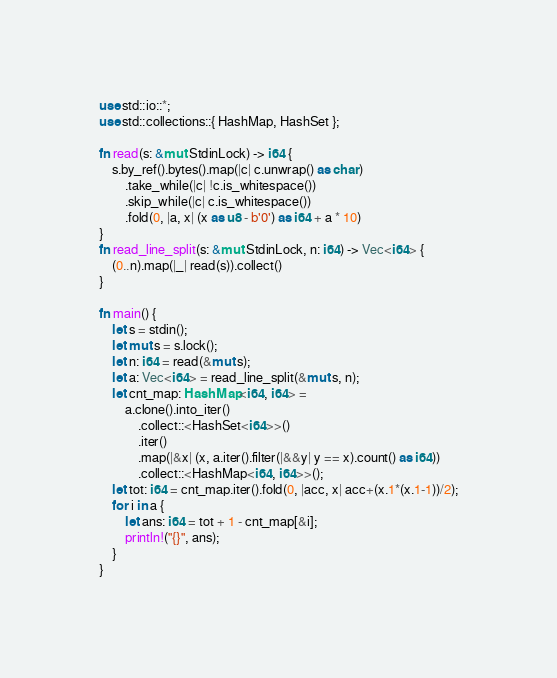Convert code to text. <code><loc_0><loc_0><loc_500><loc_500><_Rust_>use std::io::*;
use std::collections::{ HashMap, HashSet };

fn read(s: &mut StdinLock) -> i64 {
    s.by_ref().bytes().map(|c| c.unwrap() as char)
        .take_while(|c| !c.is_whitespace())
        .skip_while(|c| c.is_whitespace())
        .fold(0, |a, x| (x as u8 - b'0') as i64 + a * 10)
}
fn read_line_split(s: &mut StdinLock, n: i64) -> Vec<i64> {
    (0..n).map(|_| read(s)).collect()
}

fn main() {
    let s = stdin();
    let mut s = s.lock();
    let n: i64 = read(&mut s);
    let a: Vec<i64> = read_line_split(&mut s, n);
    let cnt_map: HashMap<i64, i64> = 
        a.clone().into_iter()
            .collect::<HashSet<i64>>()
            .iter()
            .map(|&x| (x, a.iter().filter(|&&y| y == x).count() as i64))
            .collect::<HashMap<i64, i64>>();
    let tot: i64 = cnt_map.iter().fold(0, |acc, x| acc+(x.1*(x.1-1))/2);
    for i in a {
        let ans: i64 = tot + 1 - cnt_map[&i];
        println!("{}", ans);
    }
}</code> 